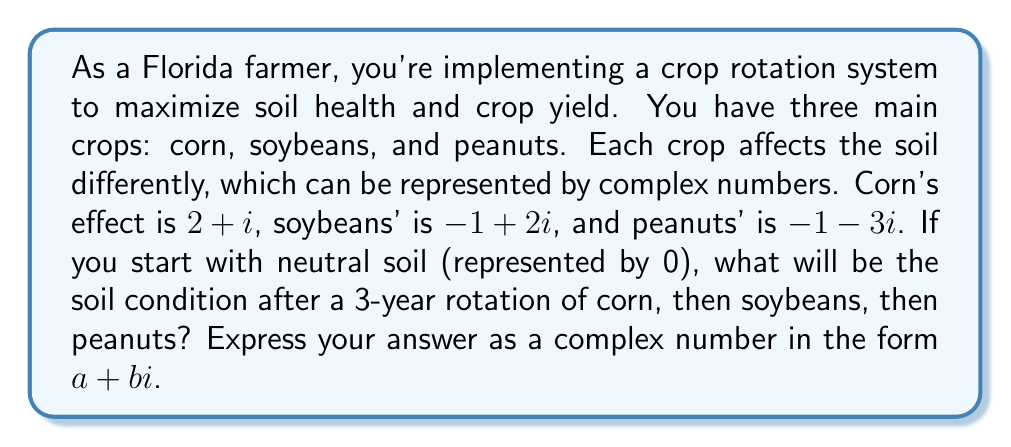What is the answer to this math problem? Let's approach this step-by-step:

1) We start with neutral soil, represented by 0.

2) Year 1 (Corn): 
   $0 + (2+i) = 2+i$

3) Year 2 (Soybeans):
   $(2+i) + (-1+2i) = (2-1) + (1+2)i = 1+3i$

4) Year 3 (Peanuts):
   $(1+3i) + (-1-3i) = (1-1) + (3-3)i = 0+0i = 0$

The complex number operations here represent the cumulative effects of the crops on the soil over time. Addition of complex numbers is done by adding the real and imaginary parts separately.

This result suggests that this particular rotation pattern brings the soil back to its neutral state after three years, which could be beneficial for long-term soil health.
Answer: $0+0i$ or simply $0$ 